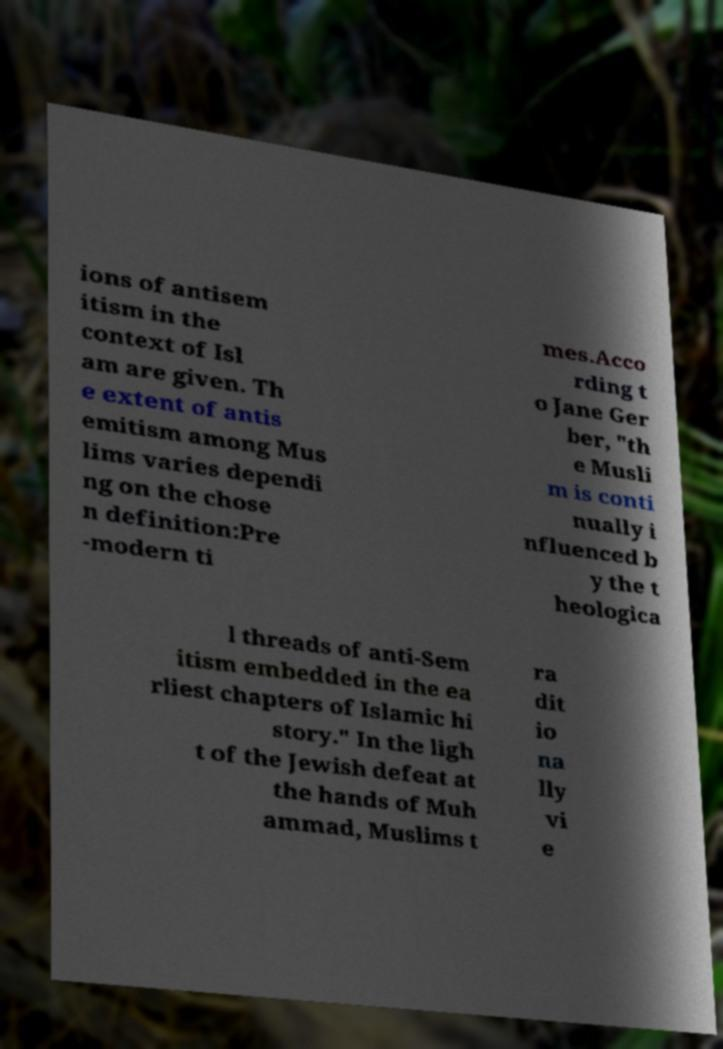Please read and relay the text visible in this image. What does it say? ions of antisem itism in the context of Isl am are given. Th e extent of antis emitism among Mus lims varies dependi ng on the chose n definition:Pre -modern ti mes.Acco rding t o Jane Ger ber, "th e Musli m is conti nually i nfluenced b y the t heologica l threads of anti-Sem itism embedded in the ea rliest chapters of Islamic hi story." In the ligh t of the Jewish defeat at the hands of Muh ammad, Muslims t ra dit io na lly vi e 